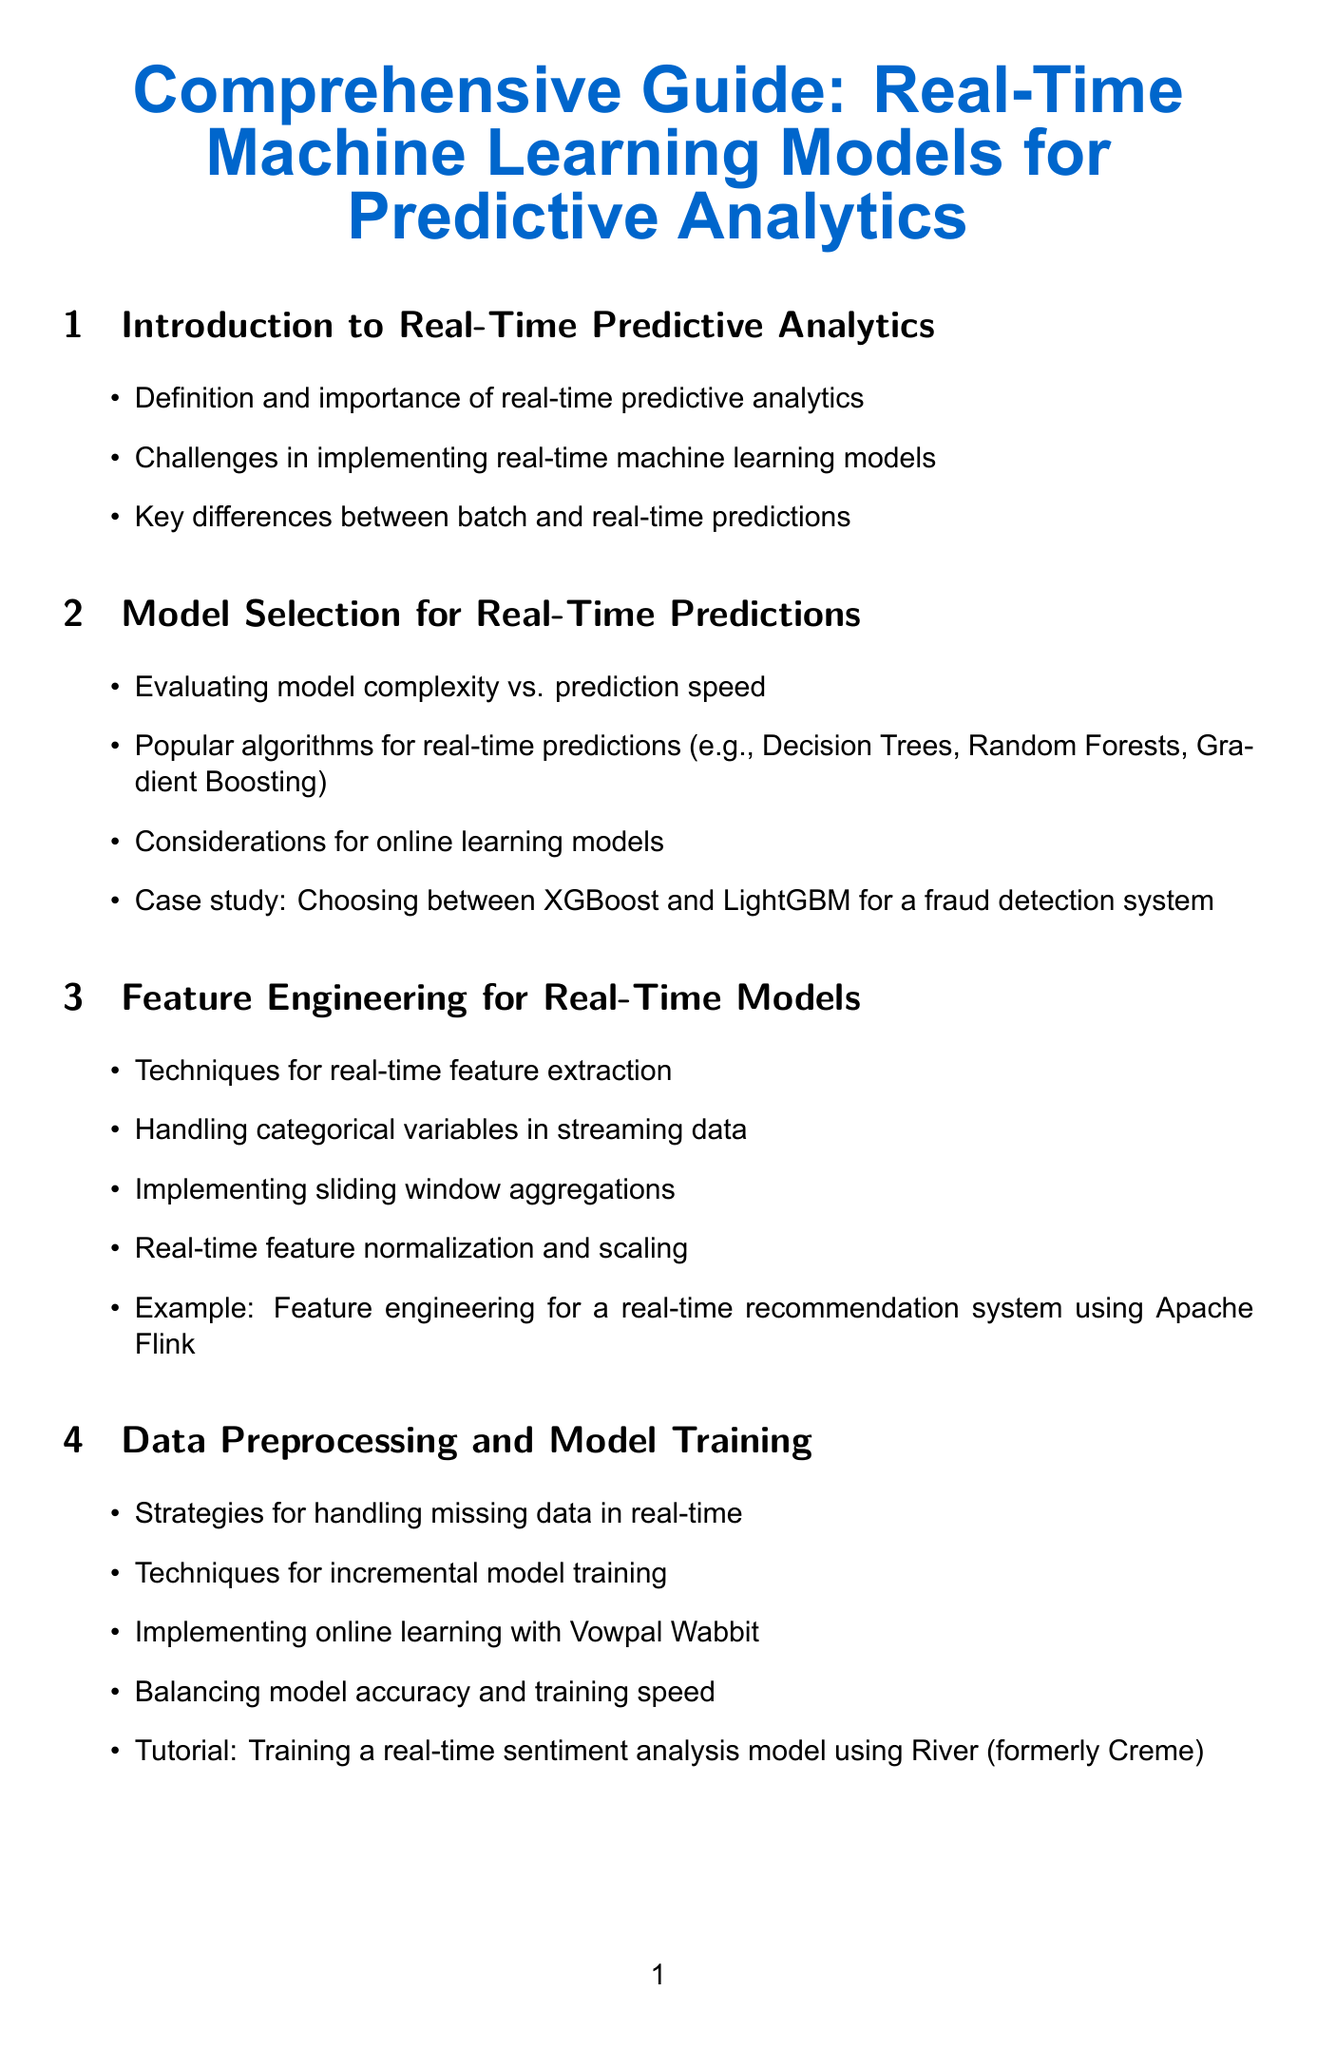What is the title of the document? The title is the main heading of the document, indicating the topic covered.
Answer: Comprehensive Guide: Real-Time Machine Learning Models for Predictive Analytics How many sections are in the document? The number of sections is counted to understand the structure of the document.
Answer: 10 What technique is suggested for handling categorical variables in streaming data? This technique is mentioned in the feature engineering section as a method to process specific data types effectively.
Answer: Handling categorical variables Which platforms are listed for integration with streaming? This lists popular tools and platforms relevant to the integration topic in the document.
Answer: Apache Kafka, Apache Flink, Apache Spark Streaming What case study is included in the model selection section? This case study illustrates a practical application for model selection, showing its relevance to real-world contexts.
Answer: Choosing between XGBoost and LightGBM for a fraud detection system What is the goal of implementing caching strategies? This goal is described to enhance system performance by improving access times for frequently used data.
Answer: Reducing model latency What type of learning is discussed in relation to Vowpal Wabbit? This learning type pertains to a specific strategy suitable for real-time model updates and improvements.
Answer: Online learning What tutorial is provided in the monitoring and maintenance section? This tutorial offers practical guidance for setting up a system to oversee model performance in real-time applications.
Answer: Setting up monitoring for a real-time fraud detection model using Prometheus and Grafana What is a key difference between batch and real-time predictions? This difference is crucial for distinguishing between two types of predictive modeling approaches discussed in the document.
Answer: Speed of prediction 